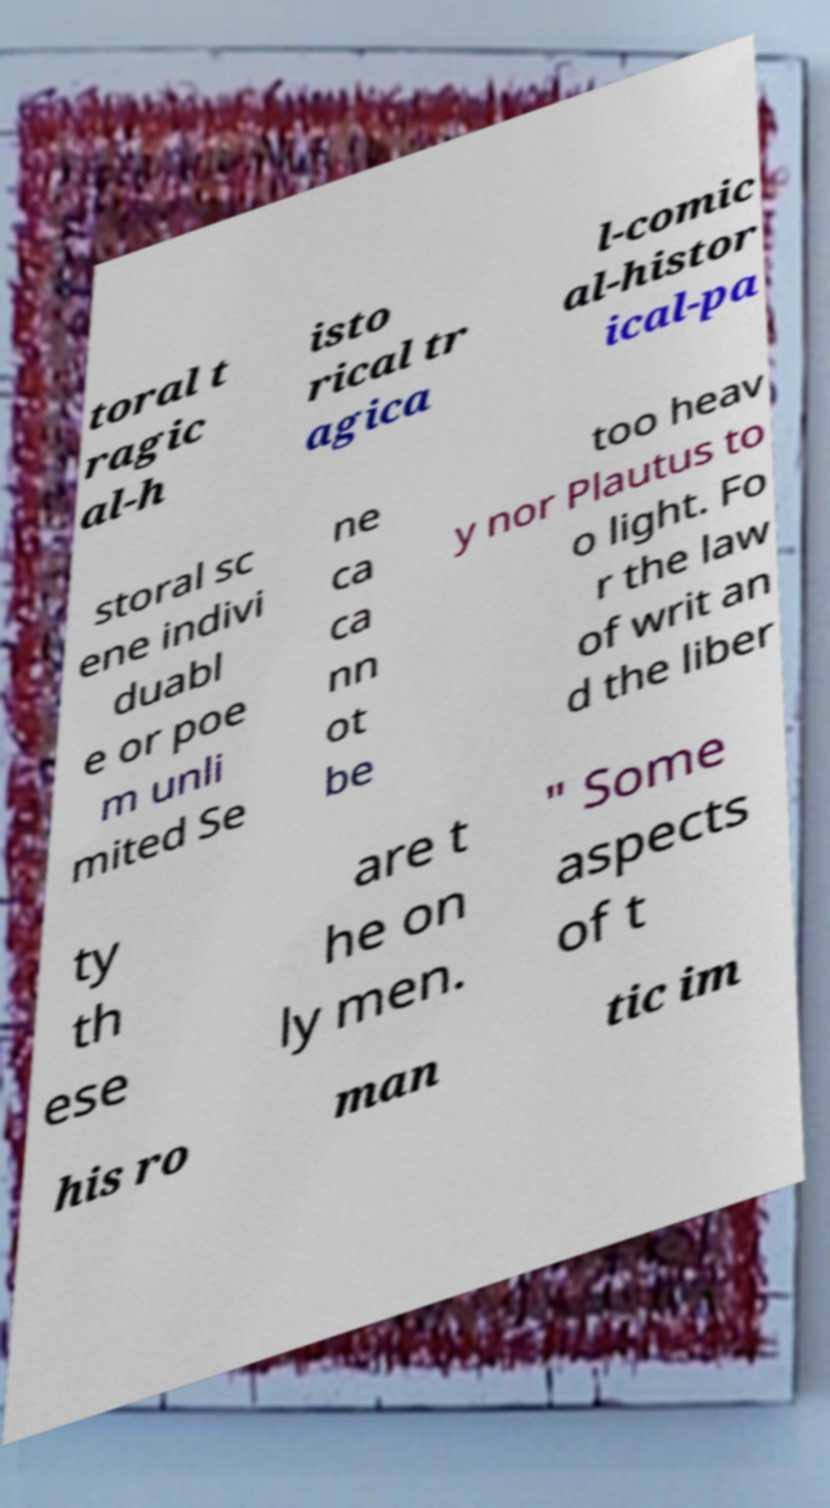Please identify and transcribe the text found in this image. toral t ragic al-h isto rical tr agica l-comic al-histor ical-pa storal sc ene indivi duabl e or poe m unli mited Se ne ca ca nn ot be too heav y nor Plautus to o light. Fo r the law of writ an d the liber ty th ese are t he on ly men. " Some aspects of t his ro man tic im 